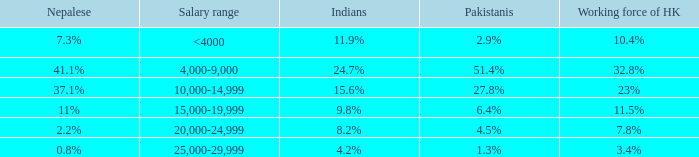If the working force of HK is 32.8%, what are the Pakistanis' %?  51.4%. 